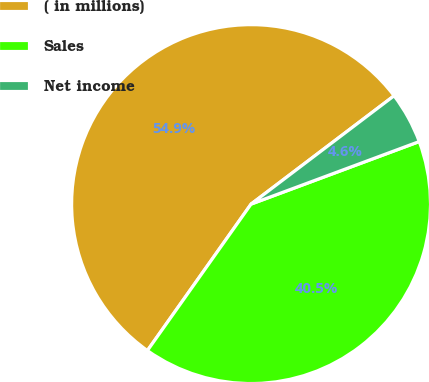Convert chart to OTSL. <chart><loc_0><loc_0><loc_500><loc_500><pie_chart><fcel>( in millions)<fcel>Sales<fcel>Net income<nl><fcel>54.88%<fcel>40.47%<fcel>4.65%<nl></chart> 